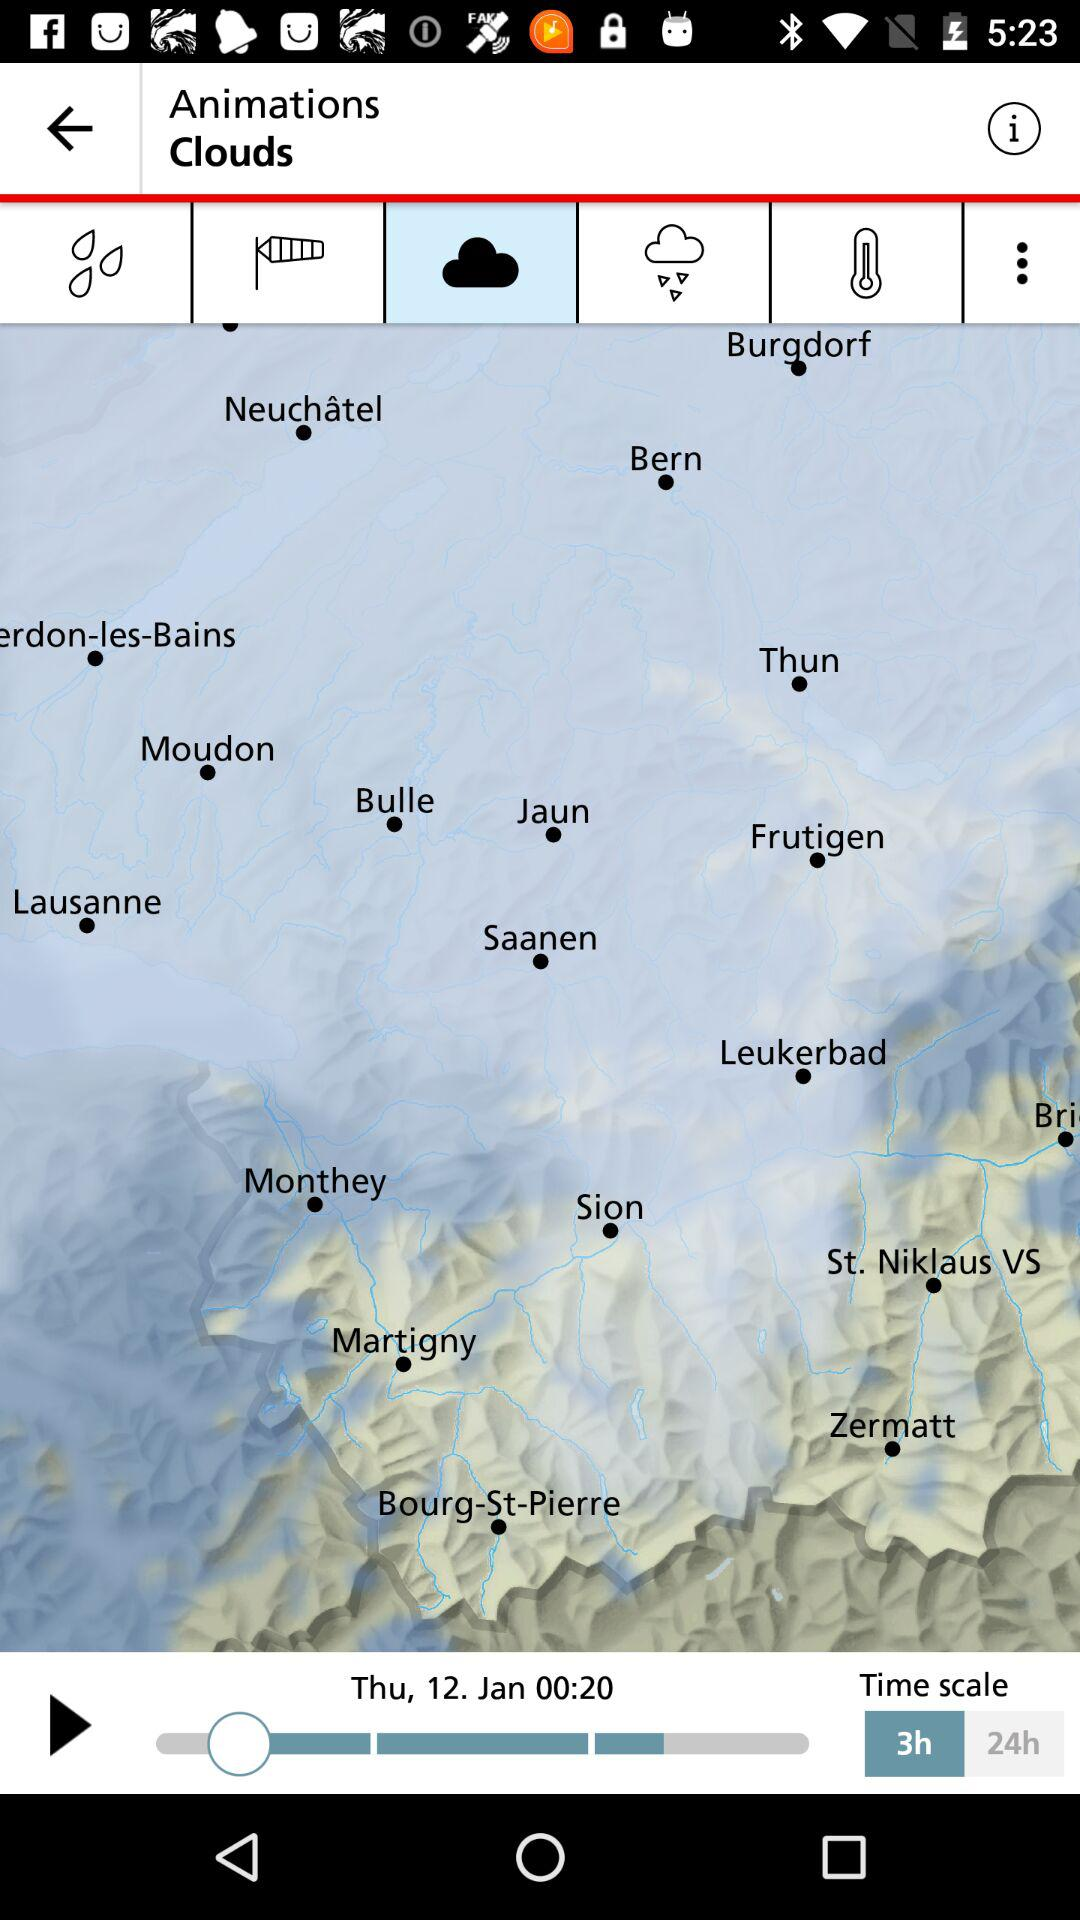What is the selected time scale? The selected time scale is 3 hours. 